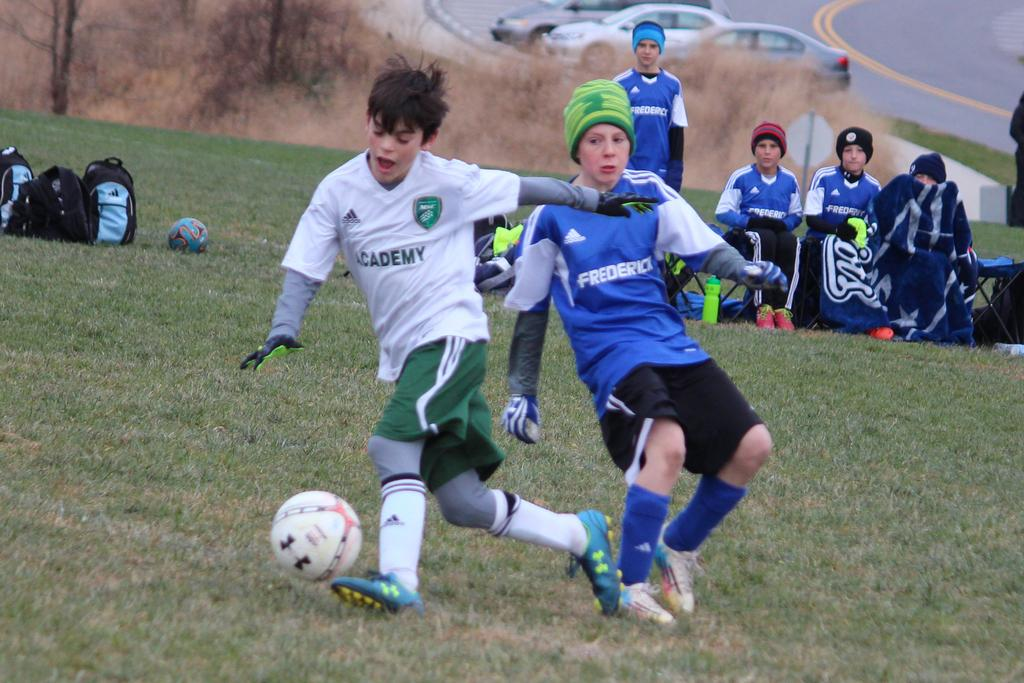Provide a one-sentence caption for the provided image. A boy wearing white "academy" soccer jersey runs with the ball past another boy in green. 